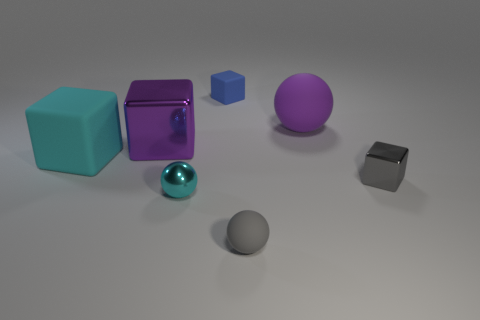Which objects stand out the most in this image and why? The large purple shiny cube immediately draws the eye due to its vibrant color and reflective surface which captures and bounces off the light. Similarly, the large matte sphere of the same color stands out not just for its size but for its smooth, non-reflective texture that provides a visual balance to the composition. 